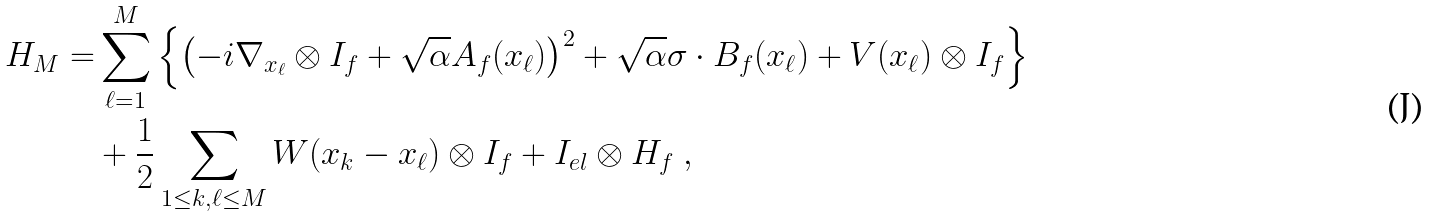<formula> <loc_0><loc_0><loc_500><loc_500>H _ { M } = & \sum _ { \ell = 1 } ^ { M } \left \{ \left ( - i \nabla _ { x _ { \ell } } \otimes I _ { f } + \sqrt { \alpha } A _ { f } ( x _ { \ell } ) \right ) ^ { 2 } + \sqrt { \alpha } \sigma \cdot B _ { f } ( x _ { \ell } ) + V ( x _ { \ell } ) \otimes I _ { f } \right \} \\ & + \frac { 1 } { 2 } \sum _ { 1 \leq k , \ell \leq M } W ( x _ { k } - x _ { \ell } ) \otimes I _ { f } + I _ { e l } \otimes H _ { f } \ ,</formula> 